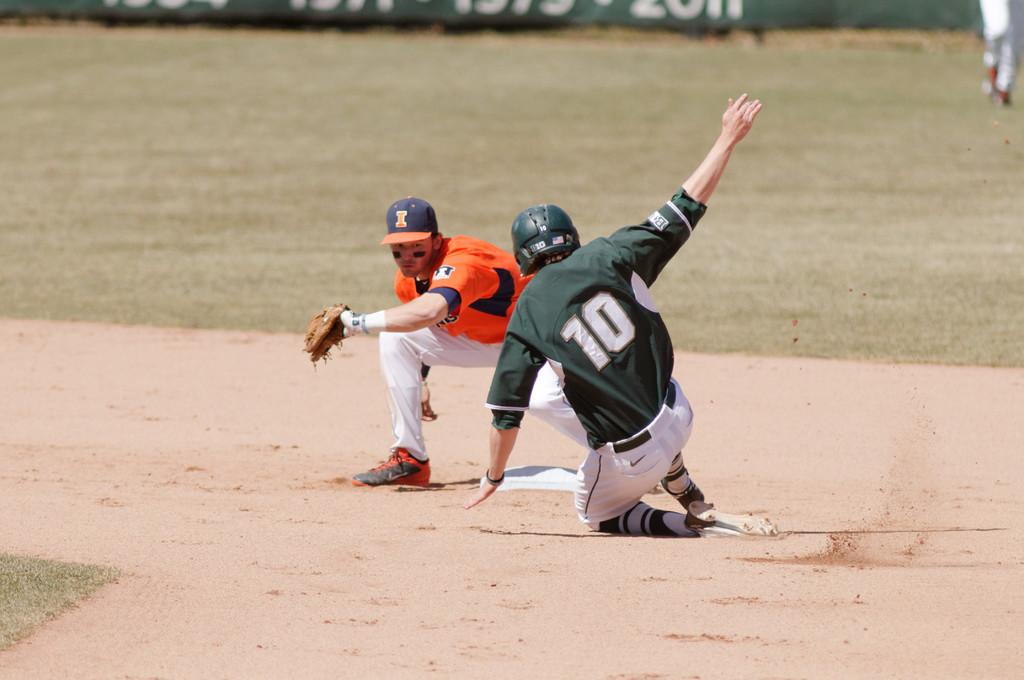<image>
Present a compact description of the photo's key features. A baseball player in a green number 10 uniform slides into base. 